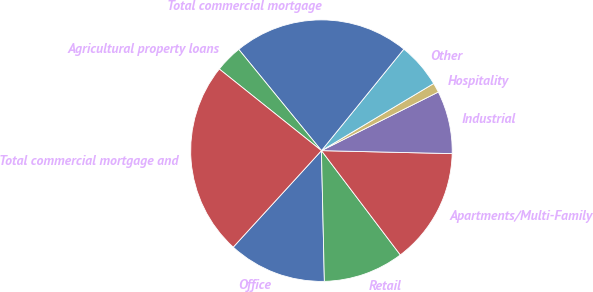Convert chart. <chart><loc_0><loc_0><loc_500><loc_500><pie_chart><fcel>Office<fcel>Retail<fcel>Apartments/Multi-Family<fcel>Industrial<fcel>Hospitality<fcel>Other<fcel>Total commercial mortgage<fcel>Agricultural property loans<fcel>Total commercial mortgage and<nl><fcel>12.14%<fcel>9.95%<fcel>14.33%<fcel>7.76%<fcel>1.18%<fcel>5.57%<fcel>21.75%<fcel>3.37%<fcel>23.94%<nl></chart> 